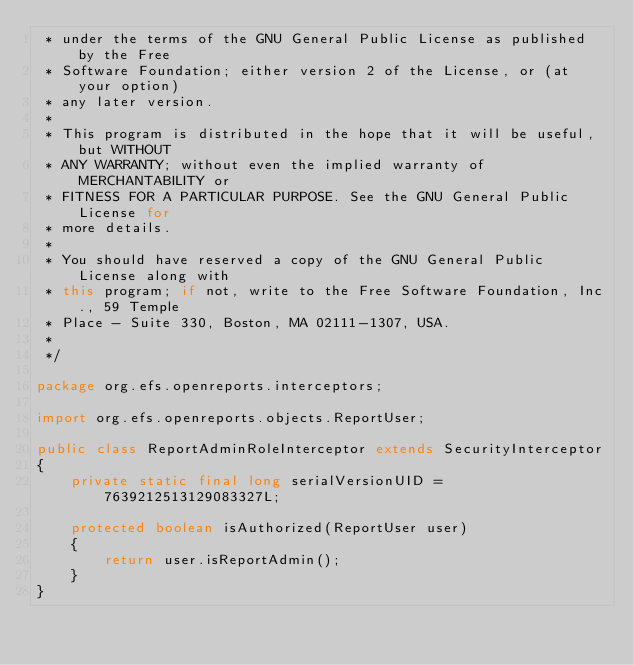Convert code to text. <code><loc_0><loc_0><loc_500><loc_500><_Java_> * under the terms of the GNU General Public License as published by the Free
 * Software Foundation; either version 2 of the License, or (at your option)
 * any later version.
 * 
 * This program is distributed in the hope that it will be useful, but WITHOUT
 * ANY WARRANTY; without even the implied warranty of MERCHANTABILITY or
 * FITNESS FOR A PARTICULAR PURPOSE. See the GNU General Public License for
 * more details.
 * 
 * You should have reserved a copy of the GNU General Public License along with
 * this program; if not, write to the Free Software Foundation, Inc., 59 Temple
 * Place - Suite 330, Boston, MA 02111-1307, USA.
 *  
 */

package org.efs.openreports.interceptors;

import org.efs.openreports.objects.ReportUser;

public class ReportAdminRoleInterceptor extends SecurityInterceptor
{	
	private static final long serialVersionUID = 7639212513129083327L;

	protected boolean isAuthorized(ReportUser user)
	{
		return user.isReportAdmin();
	}
}
</code> 